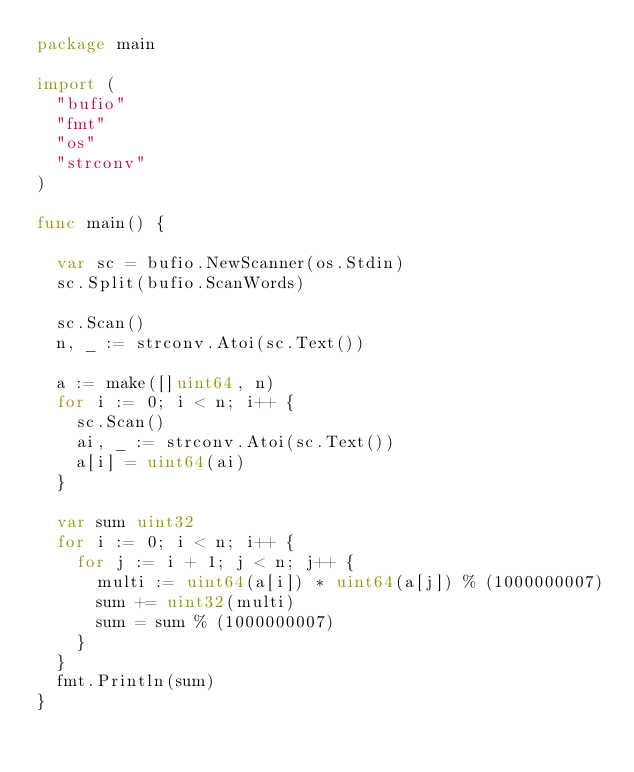<code> <loc_0><loc_0><loc_500><loc_500><_Go_>package main

import (
	"bufio"
	"fmt"
	"os"
	"strconv"
)

func main() {

	var sc = bufio.NewScanner(os.Stdin)
	sc.Split(bufio.ScanWords)

	sc.Scan()
	n, _ := strconv.Atoi(sc.Text())

	a := make([]uint64, n)
	for i := 0; i < n; i++ {
		sc.Scan()
		ai, _ := strconv.Atoi(sc.Text())
		a[i] = uint64(ai)
	}

	var sum uint32
	for i := 0; i < n; i++ {
		for j := i + 1; j < n; j++ {
			multi := uint64(a[i]) * uint64(a[j]) % (1000000007)
			sum += uint32(multi)
			sum = sum % (1000000007)
		}
	}
	fmt.Println(sum)
}
</code> 